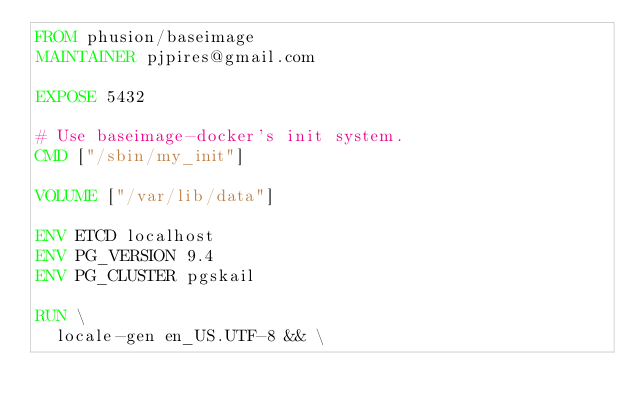Convert code to text. <code><loc_0><loc_0><loc_500><loc_500><_Dockerfile_>FROM phusion/baseimage
MAINTAINER pjpires@gmail.com

EXPOSE 5432

# Use baseimage-docker's init system.
CMD ["/sbin/my_init"]

VOLUME ["/var/lib/data"]

ENV ETCD localhost
ENV PG_VERSION 9.4
ENV PG_CLUSTER pgskail

RUN \
  locale-gen en_US.UTF-8 && \</code> 